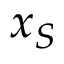<formula> <loc_0><loc_0><loc_500><loc_500>x _ { S }</formula> 